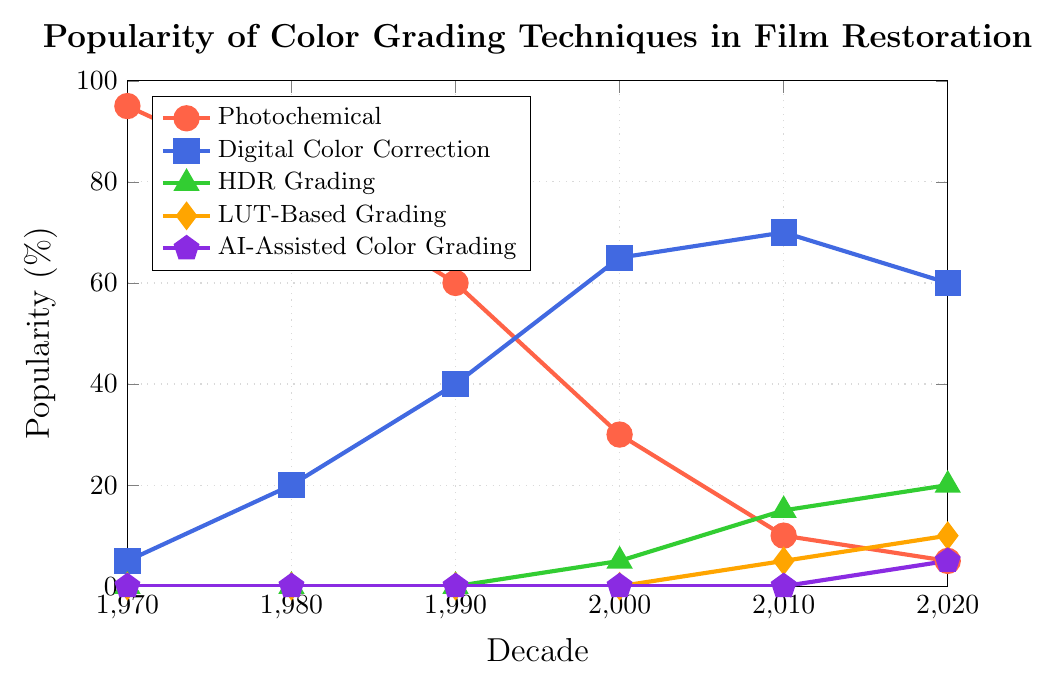What's the overall trend in the popularity of Photochemical color grading from the 1970s to the 2020s? The popularity of Photochemical color grading starts at 95% in the 1970s and decreases continuously down to 5% in the 2020s. This indicates a declining trend across the decades.
Answer: Declining trend How did the popularity of Digital Color Correction change from the 1990s to the 2010s? Observing the line for Digital Color Correction, it starts at 40% in the 1990s, increases to 65% in the 2000s, and then rises further to 70% in the 2010s, showing a steadily increasing trend.
Answer: Increased Which color grading technique had the highest popularity in the 1980s? By examining the y-values for each technique at the 1980s mark, Photochemical is at 80%, Digital Color Correction is at 20%, HDR Grading, LUT-Based Grading, and AI-Assisted Color Grading are all at 0%. Photochemical has the highest popularity.
Answer: Photochemical What is the sum of the popularity percentages of LUT-Based Grading and AI-Assisted Color Grading in the 2020s? The popularity of LUT-Based Grading in the 2020s is 10%, and for AI-Assisted Color Grading, it is 5%. Adding these together gives 10% + 5% = 15%.
Answer: 15% By how much did HDR Grading's popularity increase from the 2000s to the 2020s? In the 2000s, HDR Grading is at 5%, and it rises to 20% in the 2020s. The increase is calculated as 20% - 5% = 15%.
Answer: 15% Which technique shows a new entry in popularity starting only in the 2000s? By examining the initial points of each line, HDR Grading starts appearing in the 2000s at 5%, whereas other techniques had earlier entries or later.
Answer: HDR Grading What is the difference in popularity between Digital Color Correction and Photochemical in the 2020s? In the 2020s, Digital Color Correction is at 60% and Photochemical is at 5%. The difference is 60% - 5% = 55%.
Answer: 55% Between which decades did Photochemical's popularity drop the most rapidly? Analyzing the drops between decades shows that from the 2000s to the 2010s, there is a significant drop from 30% to 10%, a reduction of 20%. This is the highest drop compared to other consecutive decades.
Answer: 2000s to 2010s What decade sees the emergence of AI-Assisted Color Grading? Observing the data points, AI-Assisted Color Grading appears on the chart starting in the 2020s at 5%.
Answer: 2020s How much more popular is Digital Color Correction compared to Photochemical in the 2010s? Digital Color Correction has a popularity of 70% in the 2010s while Photochemical is at 10%. The difference is 70% - 10% = 60%.
Answer: 60% 